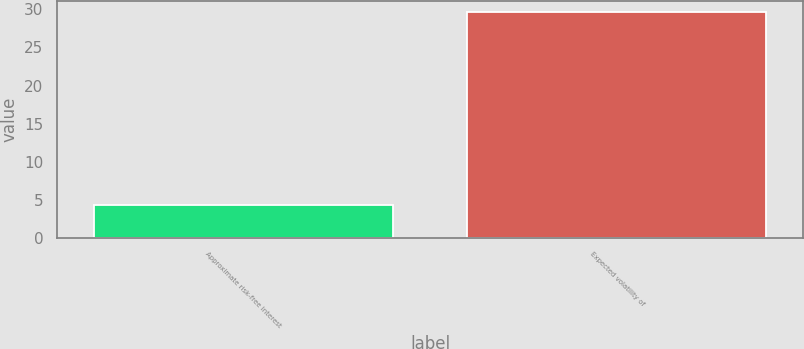Convert chart to OTSL. <chart><loc_0><loc_0><loc_500><loc_500><bar_chart><fcel>Approximate risk-free interest<fcel>Expected volatility of<nl><fcel>4.3<fcel>29.6<nl></chart> 